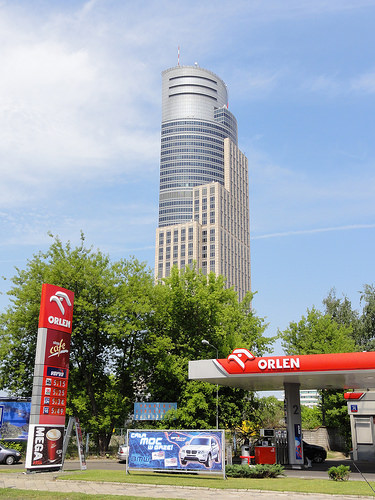<image>
Is there a car behind the sign? Yes. From this viewpoint, the car is positioned behind the sign, with the sign partially or fully occluding the car. Where is the building in relation to the tree? Is it behind the tree? Yes. From this viewpoint, the building is positioned behind the tree, with the tree partially or fully occluding the building. 